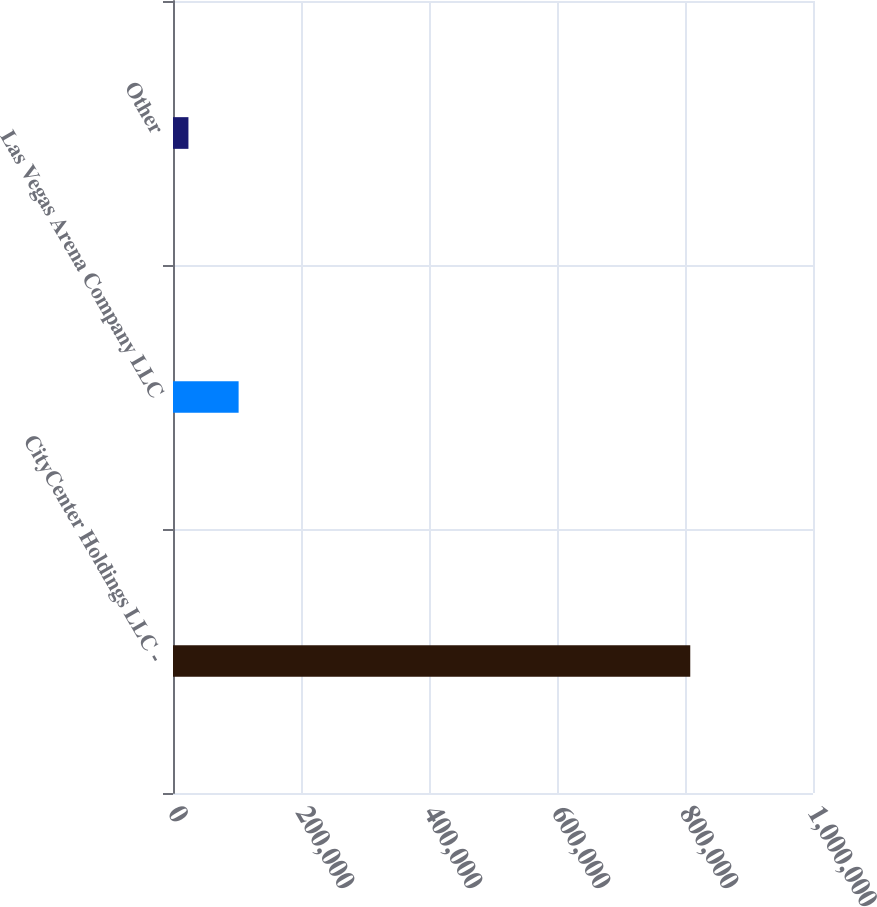<chart> <loc_0><loc_0><loc_500><loc_500><bar_chart><fcel>CityCenter Holdings LLC -<fcel>Las Vegas Arena Company LLC<fcel>Other<nl><fcel>808220<fcel>102526<fcel>24116<nl></chart> 